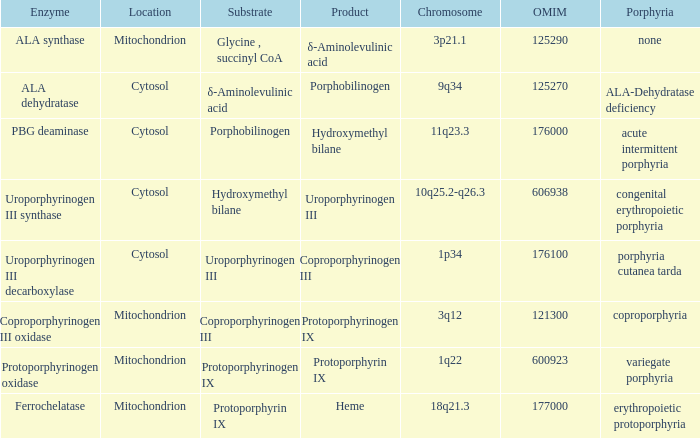Which substrate contains an omim of 176000? Porphobilinogen. 